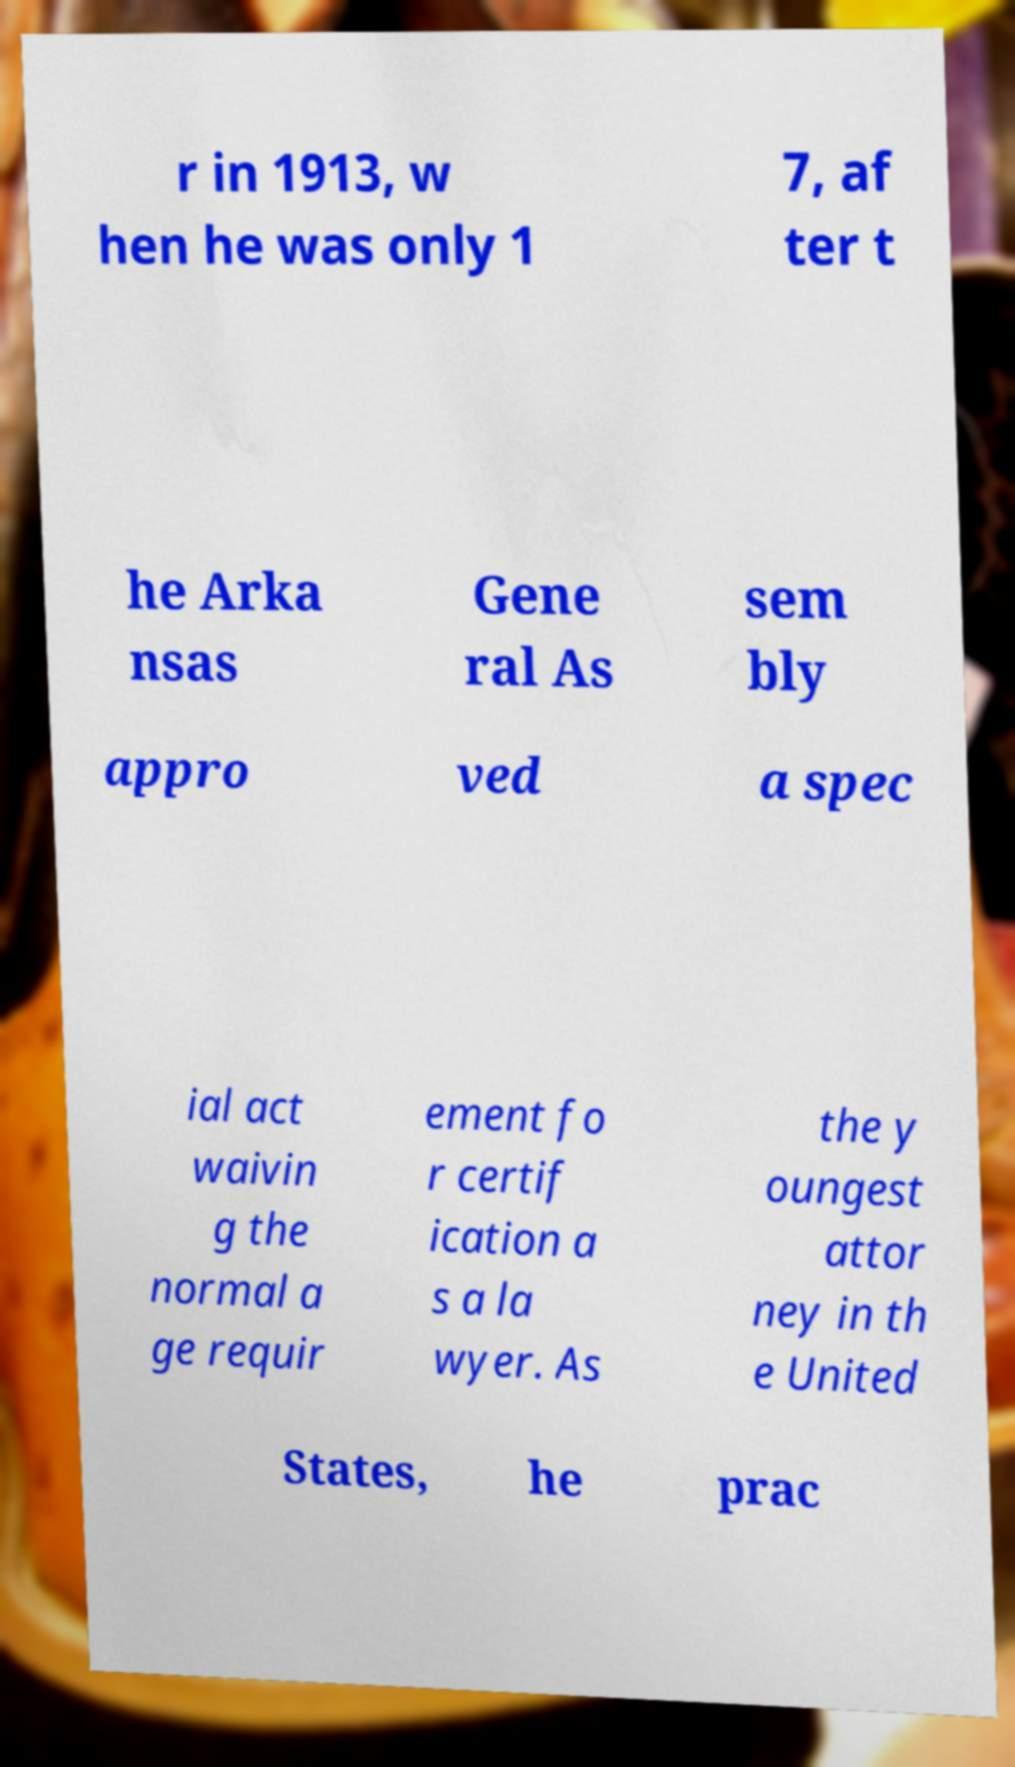Can you accurately transcribe the text from the provided image for me? r in 1913, w hen he was only 1 7, af ter t he Arka nsas Gene ral As sem bly appro ved a spec ial act waivin g the normal a ge requir ement fo r certif ication a s a la wyer. As the y oungest attor ney in th e United States, he prac 